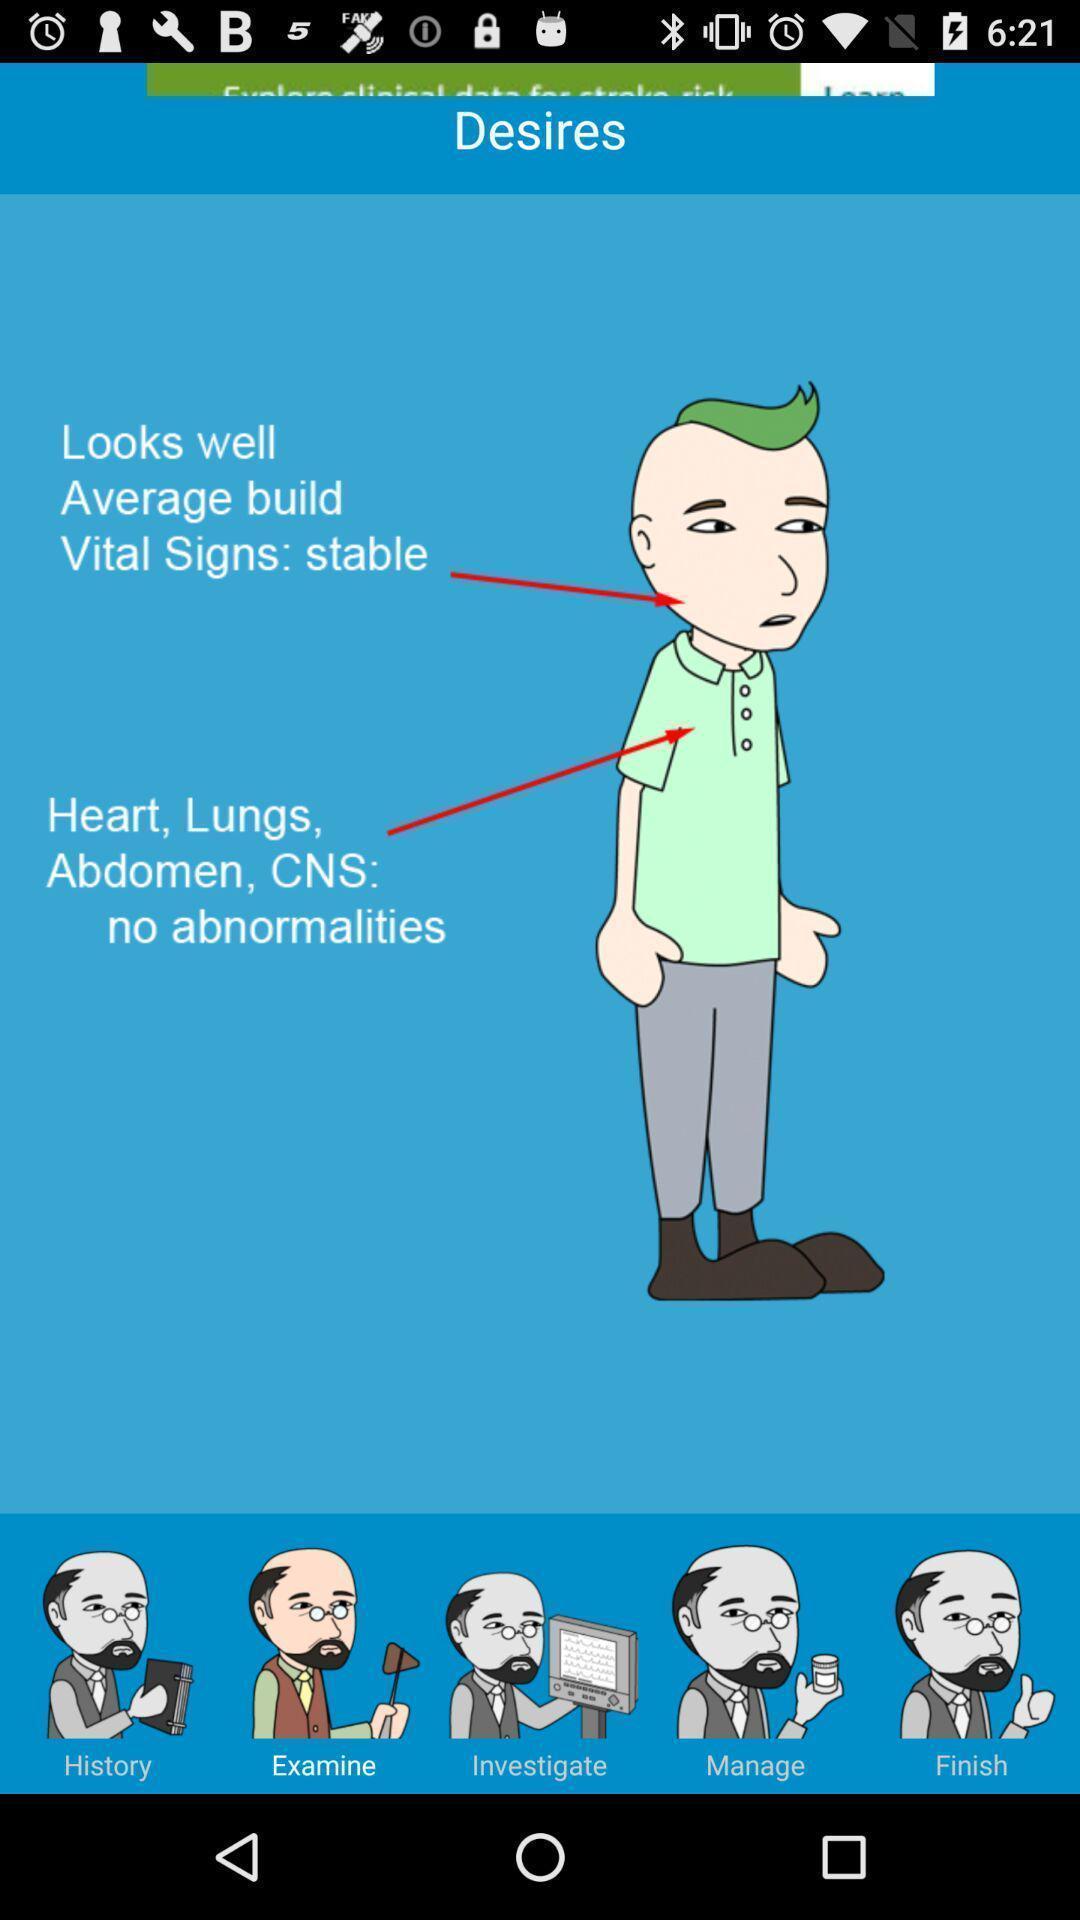Summarize the main components in this picture. Page displays various options in app. 